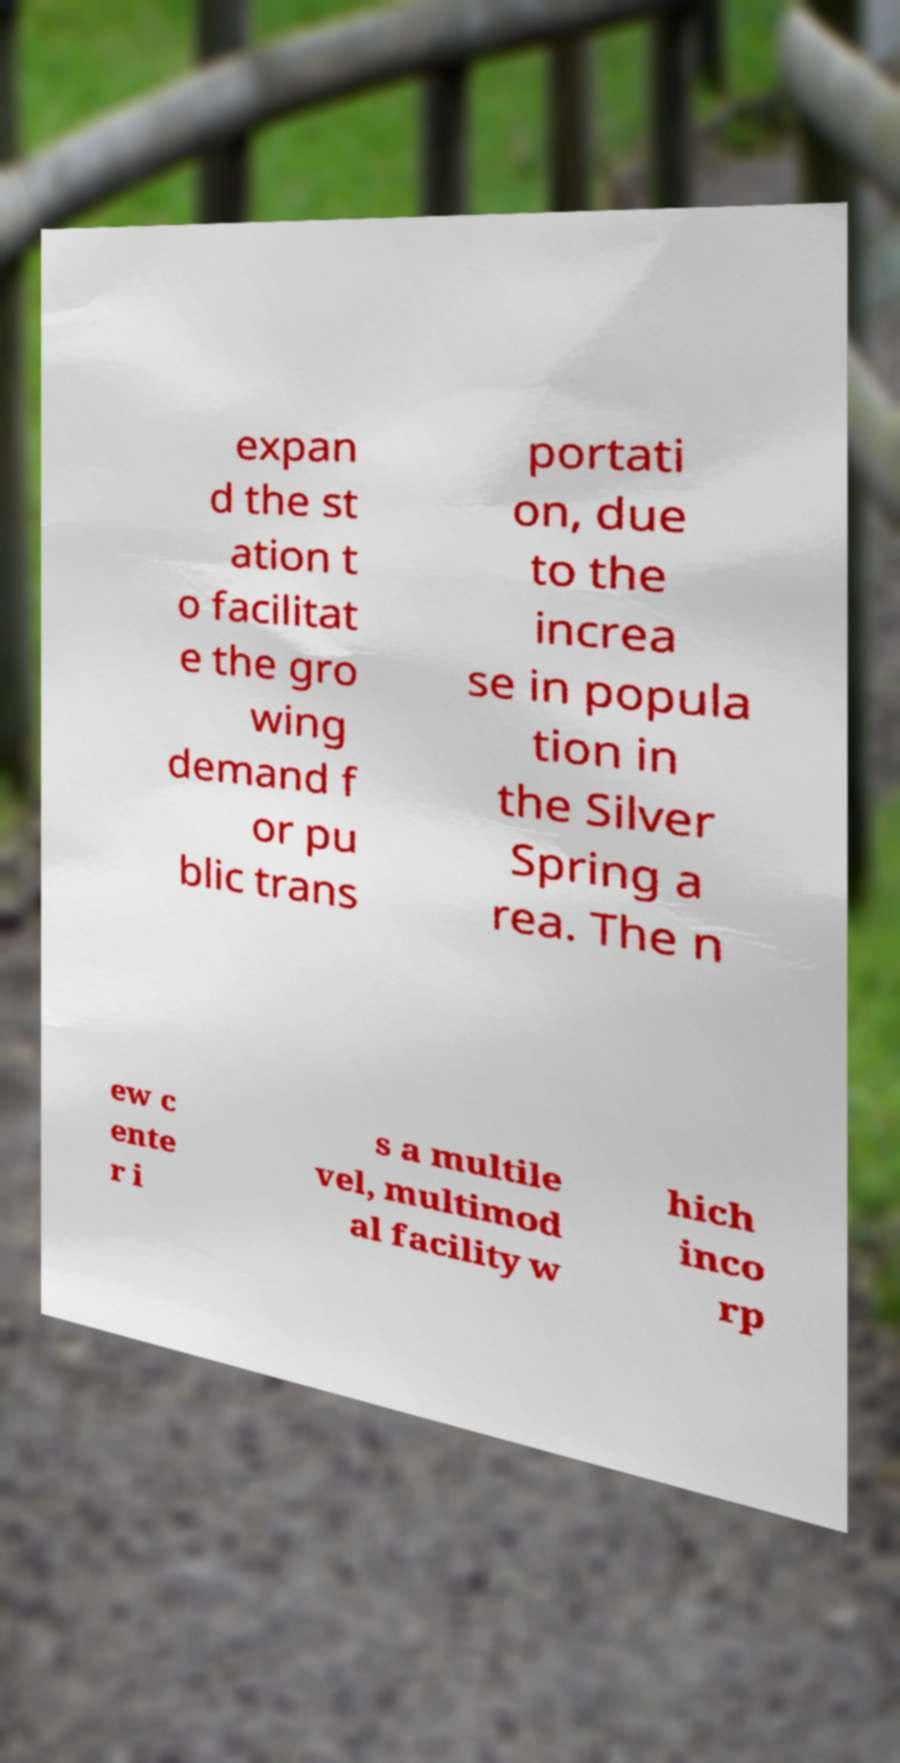Please identify and transcribe the text found in this image. expan d the st ation t o facilitat e the gro wing demand f or pu blic trans portati on, due to the increa se in popula tion in the Silver Spring a rea. The n ew c ente r i s a multile vel, multimod al facility w hich inco rp 